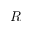Convert formula to latex. <formula><loc_0><loc_0><loc_500><loc_500>R</formula> 